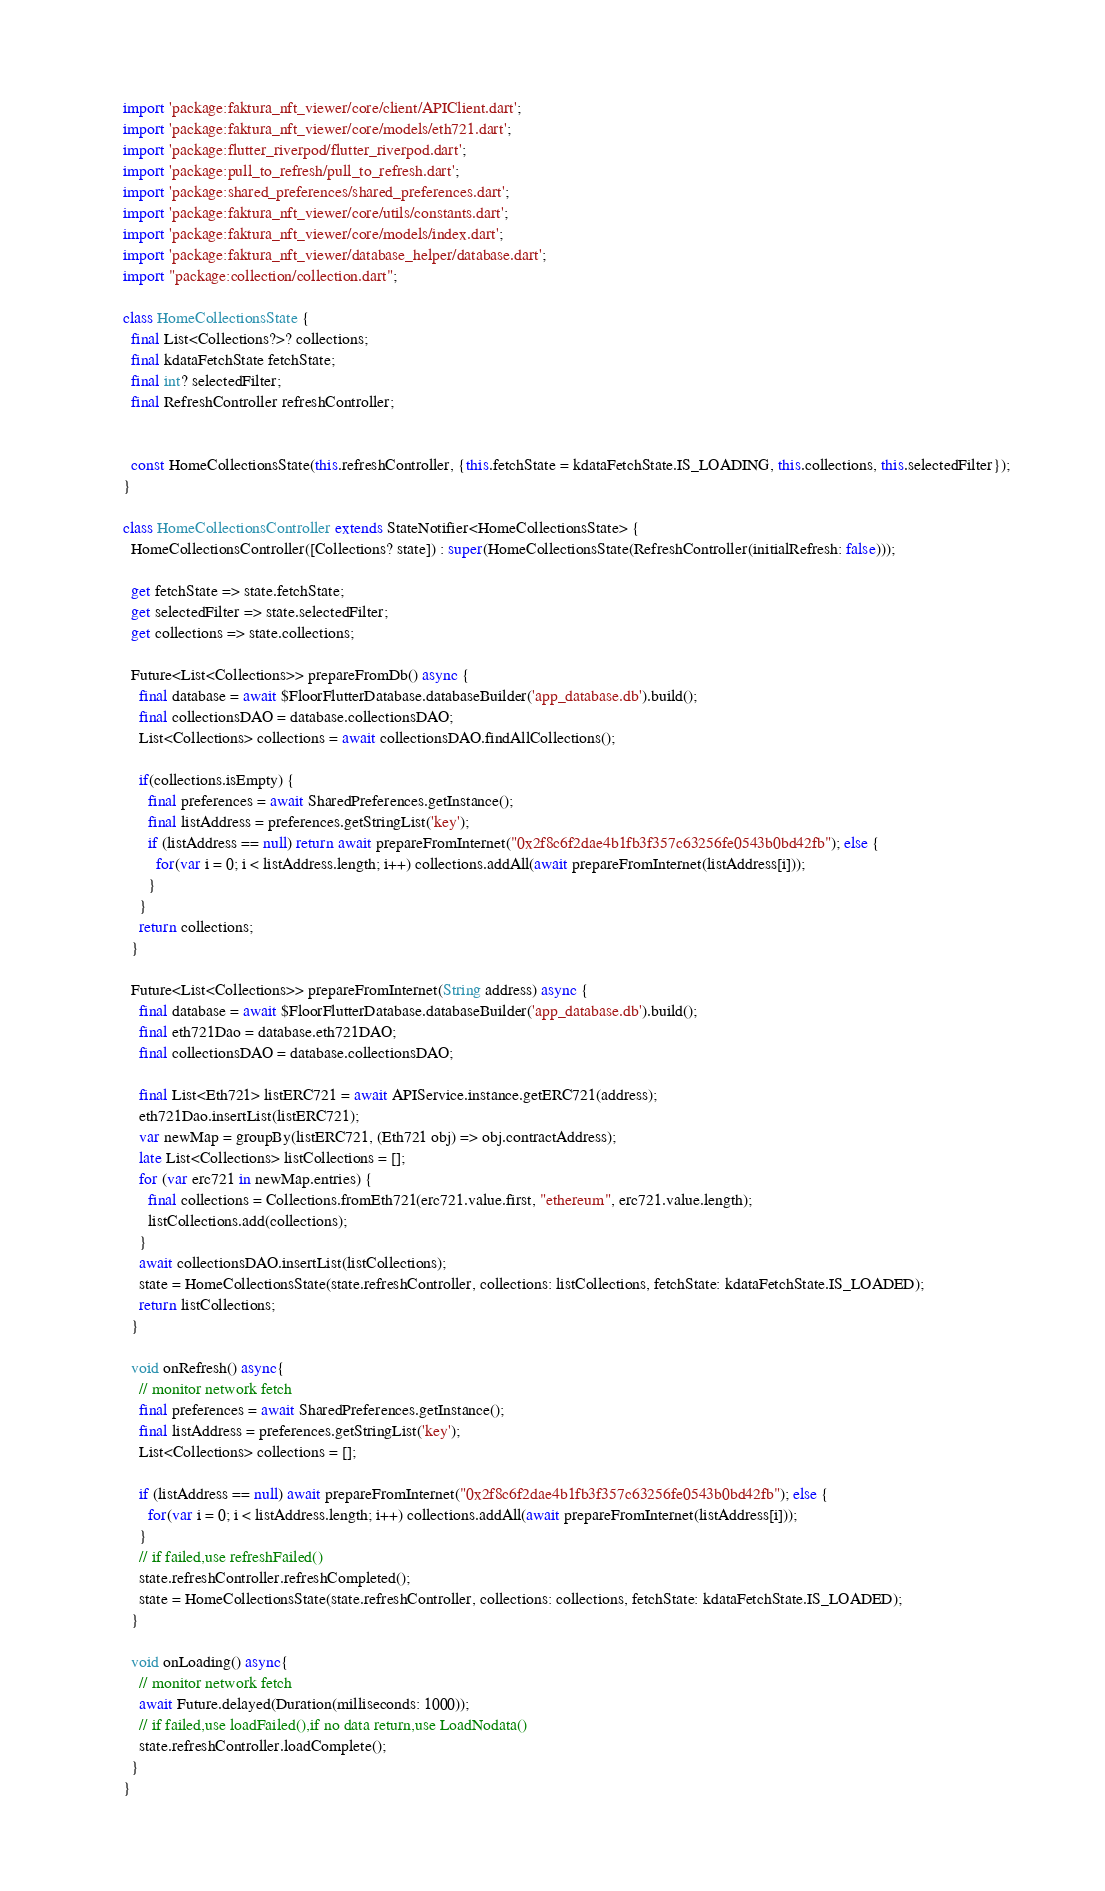<code> <loc_0><loc_0><loc_500><loc_500><_Dart_>import 'package:faktura_nft_viewer/core/client/APIClient.dart';
import 'package:faktura_nft_viewer/core/models/eth721.dart';
import 'package:flutter_riverpod/flutter_riverpod.dart';
import 'package:pull_to_refresh/pull_to_refresh.dart';
import 'package:shared_preferences/shared_preferences.dart';
import 'package:faktura_nft_viewer/core/utils/constants.dart';
import 'package:faktura_nft_viewer/core/models/index.dart';
import 'package:faktura_nft_viewer/database_helper/database.dart';
import "package:collection/collection.dart";

class HomeCollectionsState {
  final List<Collections?>? collections;
  final kdataFetchState fetchState;
  final int? selectedFilter;
  final RefreshController refreshController;


  const HomeCollectionsState(this.refreshController, {this.fetchState = kdataFetchState.IS_LOADING, this.collections, this.selectedFilter});
}

class HomeCollectionsController extends StateNotifier<HomeCollectionsState> {
  HomeCollectionsController([Collections? state]) : super(HomeCollectionsState(RefreshController(initialRefresh: false)));

  get fetchState => state.fetchState;
  get selectedFilter => state.selectedFilter;
  get collections => state.collections;

  Future<List<Collections>> prepareFromDb() async {
    final database = await $FloorFlutterDatabase.databaseBuilder('app_database.db').build();
    final collectionsDAO = database.collectionsDAO;
    List<Collections> collections = await collectionsDAO.findAllCollections();

    if(collections.isEmpty) {
      final preferences = await SharedPreferences.getInstance();
      final listAddress = preferences.getStringList('key');
      if (listAddress == null) return await prepareFromInternet("0x2f8c6f2dae4b1fb3f357c63256fe0543b0bd42fb"); else {
        for(var i = 0; i < listAddress.length; i++) collections.addAll(await prepareFromInternet(listAddress[i]));
      }
    }
    return collections;
  }

  Future<List<Collections>> prepareFromInternet(String address) async {
    final database = await $FloorFlutterDatabase.databaseBuilder('app_database.db').build();
    final eth721Dao = database.eth721DAO;
    final collectionsDAO = database.collectionsDAO;

    final List<Eth721> listERC721 = await APIService.instance.getERC721(address);
    eth721Dao.insertList(listERC721);
    var newMap = groupBy(listERC721, (Eth721 obj) => obj.contractAddress);
    late List<Collections> listCollections = [];
    for (var erc721 in newMap.entries) {
      final collections = Collections.fromEth721(erc721.value.first, "ethereum", erc721.value.length);
      listCollections.add(collections);
    }
    await collectionsDAO.insertList(listCollections);
    state = HomeCollectionsState(state.refreshController, collections: listCollections, fetchState: kdataFetchState.IS_LOADED);
    return listCollections;
  }

  void onRefresh() async{
    // monitor network fetch
    final preferences = await SharedPreferences.getInstance();
    final listAddress = preferences.getStringList('key');
    List<Collections> collections = [];

    if (listAddress == null) await prepareFromInternet("0x2f8c6f2dae4b1fb3f357c63256fe0543b0bd42fb"); else {
      for(var i = 0; i < listAddress.length; i++) collections.addAll(await prepareFromInternet(listAddress[i]));
    }
    // if failed,use refreshFailed()
    state.refreshController.refreshCompleted();
    state = HomeCollectionsState(state.refreshController, collections: collections, fetchState: kdataFetchState.IS_LOADED);
  }

  void onLoading() async{
    // monitor network fetch
    await Future.delayed(Duration(milliseconds: 1000));
    // if failed,use loadFailed(),if no data return,use LoadNodata()
    state.refreshController.loadComplete();
  }
}
</code> 